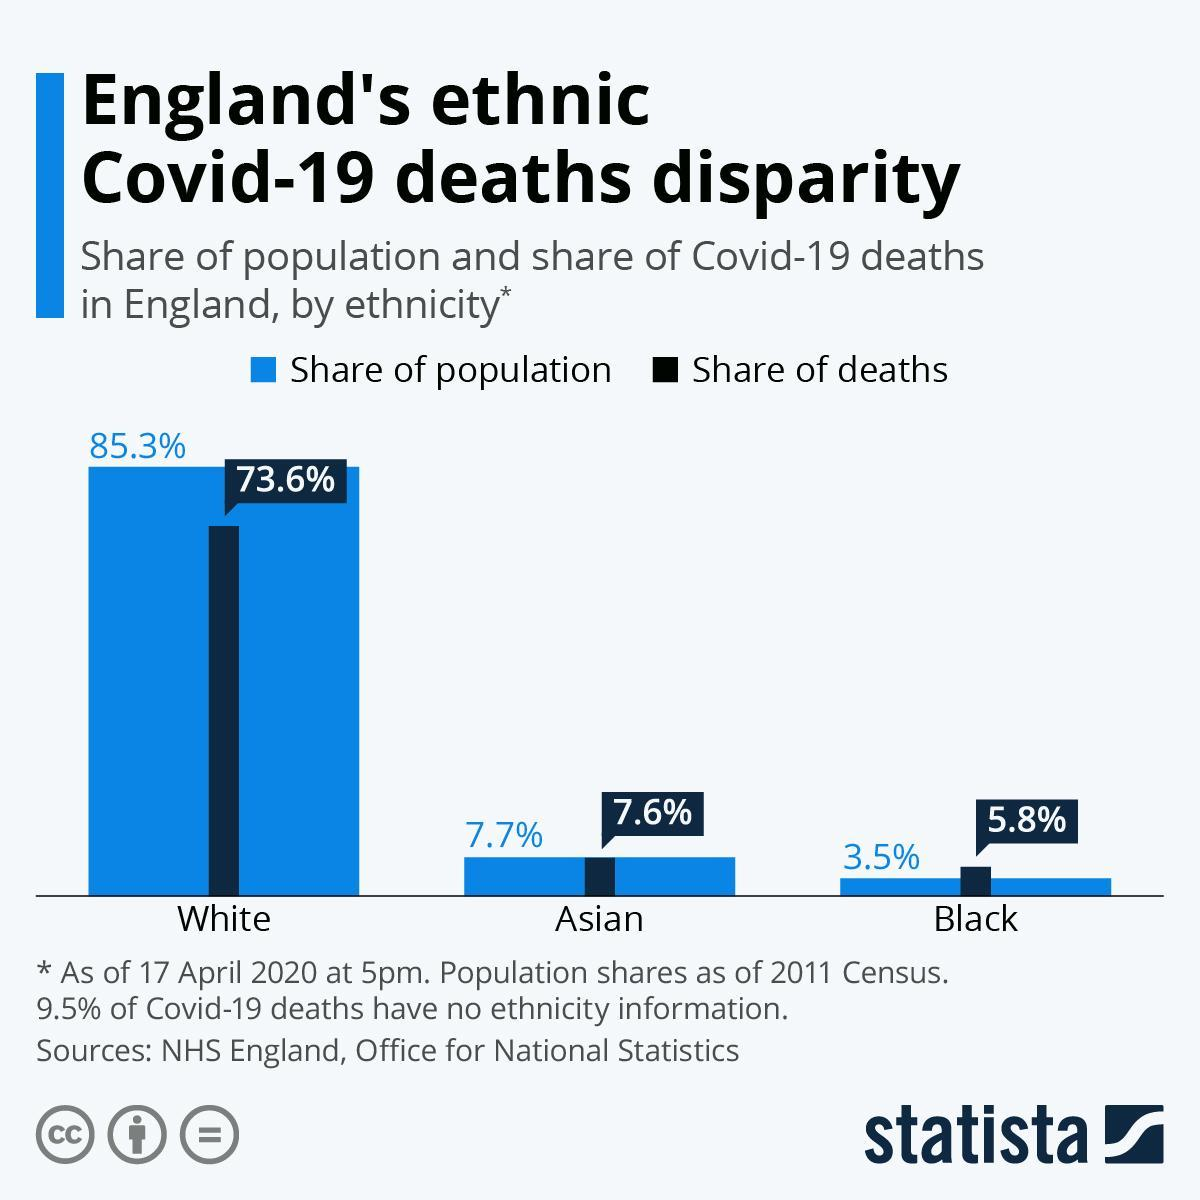How many people died in England whom are Black?
Answer the question with a short phrase. 5.8% What percentage of deaths due to Covid 19 has ethnicity information? 90.5 What is the share of population of Asian people in England? 7.7% What is the color given to the share of population- red, green, blue, yellow? blue How many people died in England whom are Asian? 7.6% For which ethnicity share of population is less than share of deaths? Black What is the share of population of Black people in England? 3.5% 